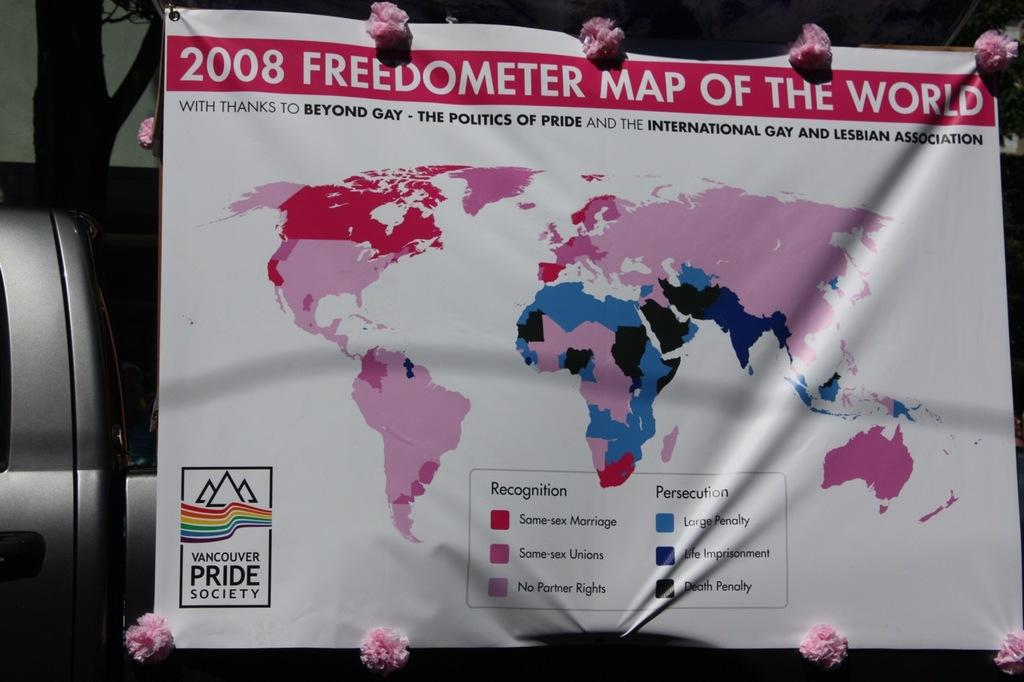What is the main object in the center of the image? There is a banner in the center of the image. What can be seen on the left side of the image? There is a vehicle and a tree on the left side of the image. Can you tell me the total amount of cents on the receipt in the image? There is no receipt present in the image, so it is not possible to determine the total amount of cents. 